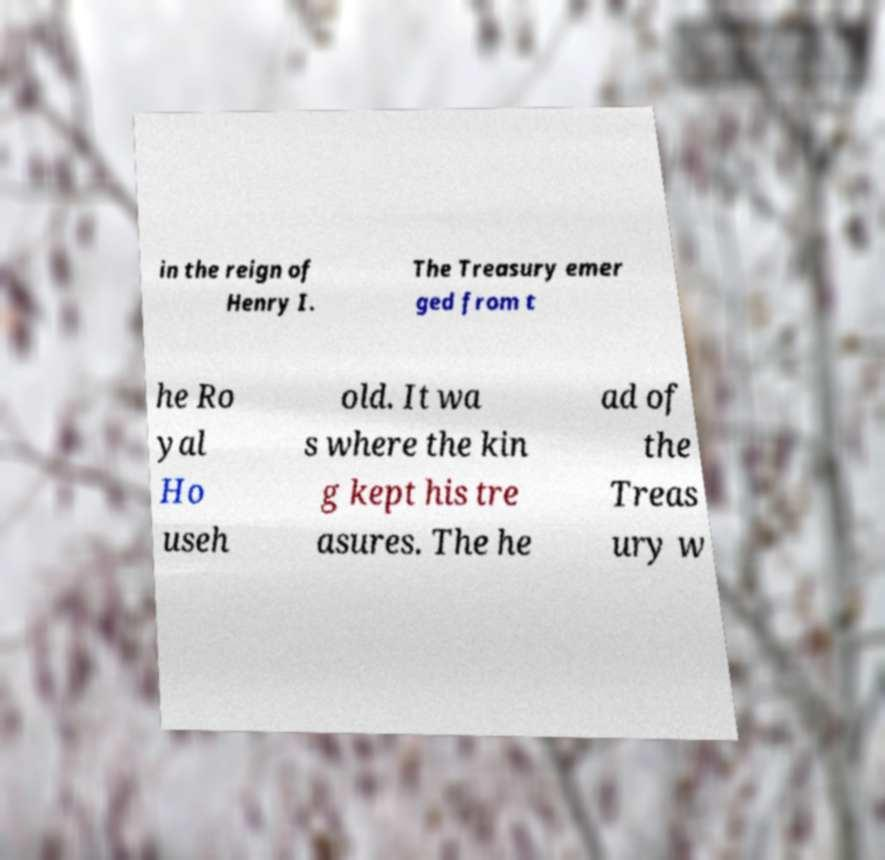Could you assist in decoding the text presented in this image and type it out clearly? in the reign of Henry I. The Treasury emer ged from t he Ro yal Ho useh old. It wa s where the kin g kept his tre asures. The he ad of the Treas ury w 